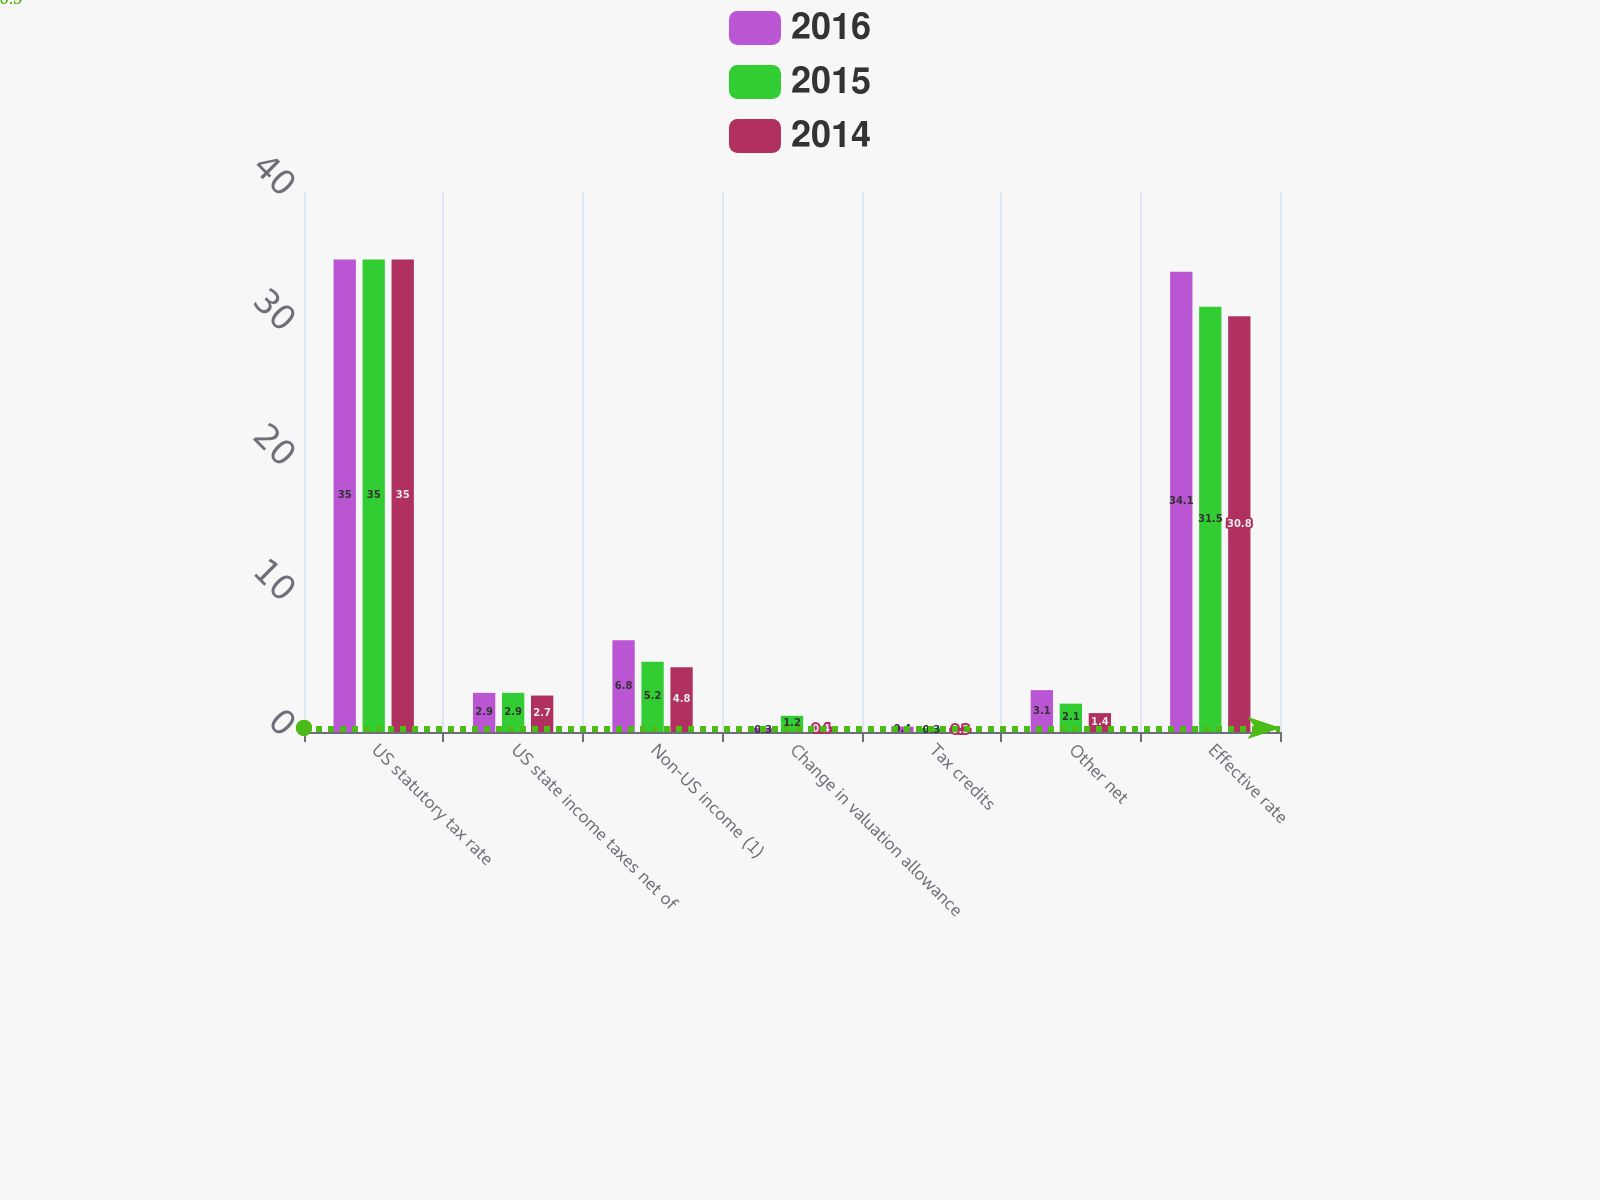<chart> <loc_0><loc_0><loc_500><loc_500><stacked_bar_chart><ecel><fcel>US statutory tax rate<fcel>US state income taxes net of<fcel>Non-US income (1)<fcel>Change in valuation allowance<fcel>Tax credits<fcel>Other net<fcel>Effective rate<nl><fcel>2016<fcel>35<fcel>2.9<fcel>6.8<fcel>0.3<fcel>0.4<fcel>3.1<fcel>34.1<nl><fcel>2015<fcel>35<fcel>2.9<fcel>5.2<fcel>1.2<fcel>0.3<fcel>2.1<fcel>31.5<nl><fcel>2014<fcel>35<fcel>2.7<fcel>4.8<fcel>0.4<fcel>0.3<fcel>1.4<fcel>30.8<nl></chart> 